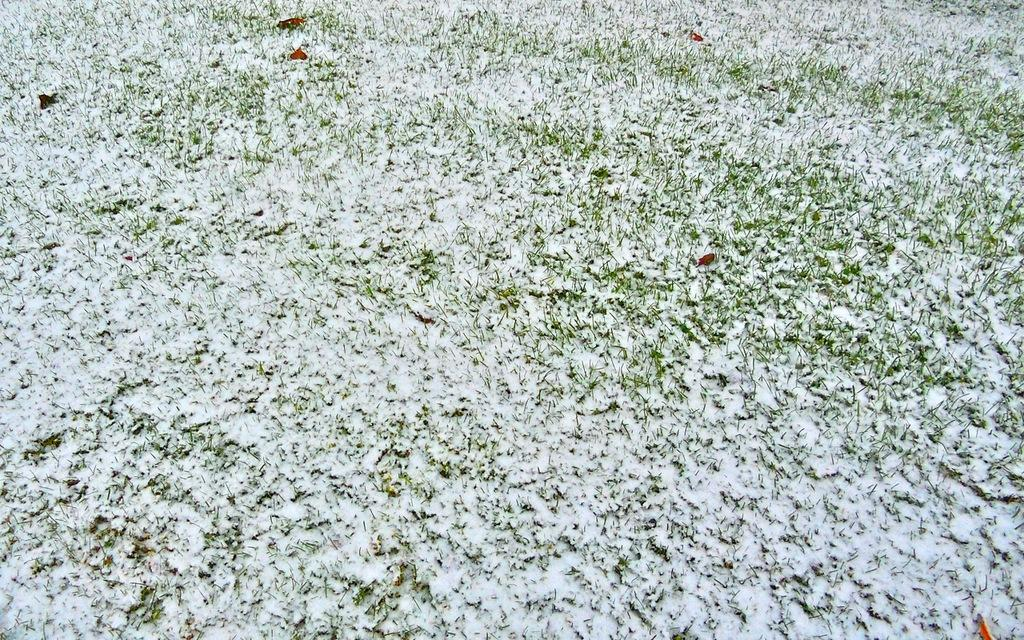What type of weather condition is depicted in the image? There is snow on the grass in the image, indicating a snowy or wintry condition. What type of protest is taking place in the image? There is no protest present in the image; it only shows snow on the grass. 